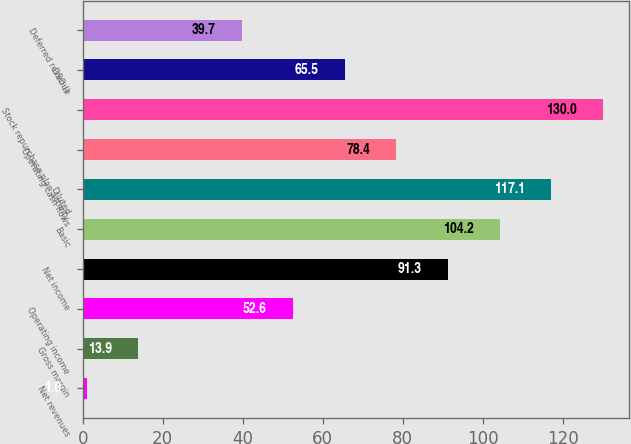<chart> <loc_0><loc_0><loc_500><loc_500><bar_chart><fcel>Net revenues<fcel>Gross margin<fcel>Operating income<fcel>Net income<fcel>Basic<fcel>Diluted<fcel>Operating cash flows<fcel>Stock repurchase plan activity<fcel>DSO ()<fcel>Deferred revenue<nl><fcel>1<fcel>13.9<fcel>52.6<fcel>91.3<fcel>104.2<fcel>117.1<fcel>78.4<fcel>130<fcel>65.5<fcel>39.7<nl></chart> 